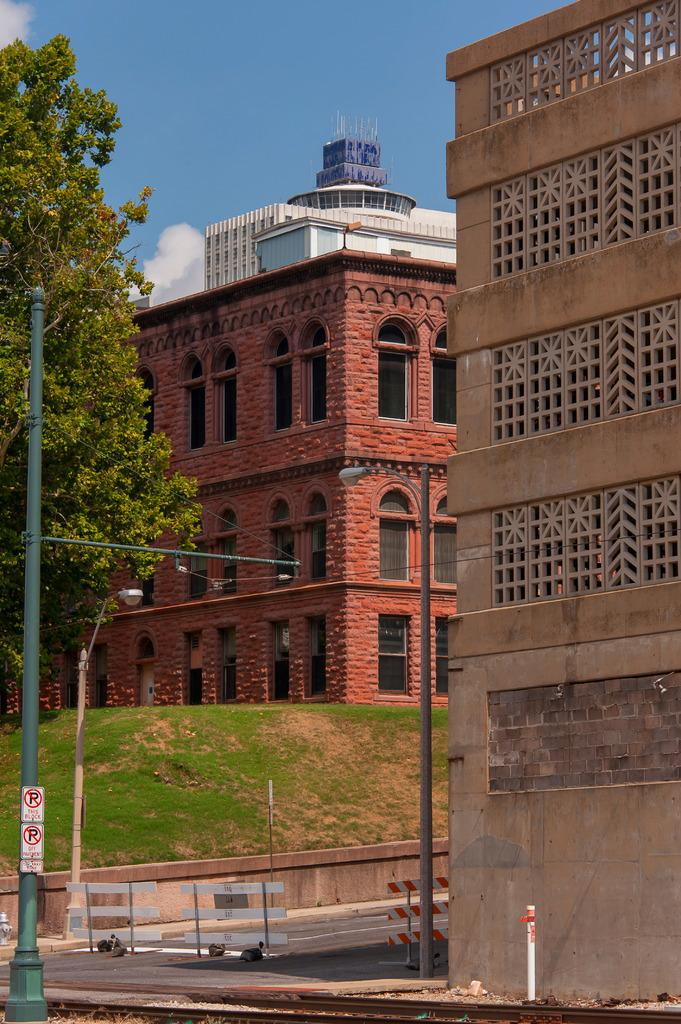What type of structures can be seen in the image? There are buildings in the image. What other objects are present in the image? There are poles, trees, a road, boards, and grass in the image. What can be seen in the background of the image? The sky is visible in the background of the image. What type of collar can be seen on the trees in the image? There are no collars present on the trees in the image; they are natural trees. What time of day is it in the image, considering the presence of the afternoon? The provided facts do not mention the time of day or the presence of an afternoon, so it cannot be determined from the image. 